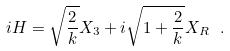<formula> <loc_0><loc_0><loc_500><loc_500>i H = \sqrt { \frac { 2 } { k } } X _ { 3 } + i \sqrt { 1 + \frac { 2 } { k } } X _ { R } \ .</formula> 